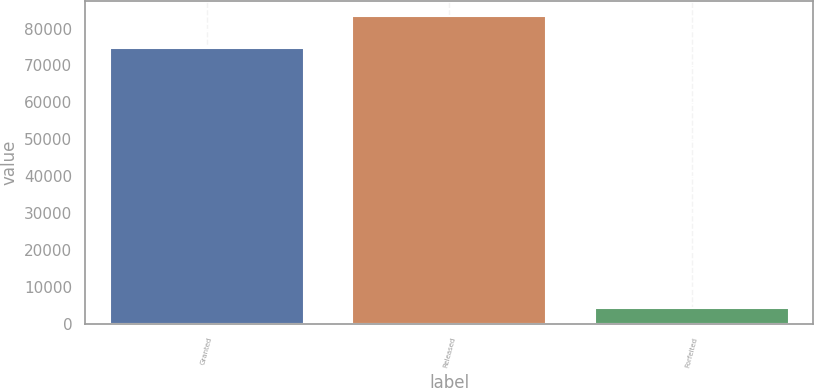<chart> <loc_0><loc_0><loc_500><loc_500><bar_chart><fcel>Granted<fcel>Released<fcel>Forfeited<nl><fcel>74850<fcel>83452<fcel>4244<nl></chart> 